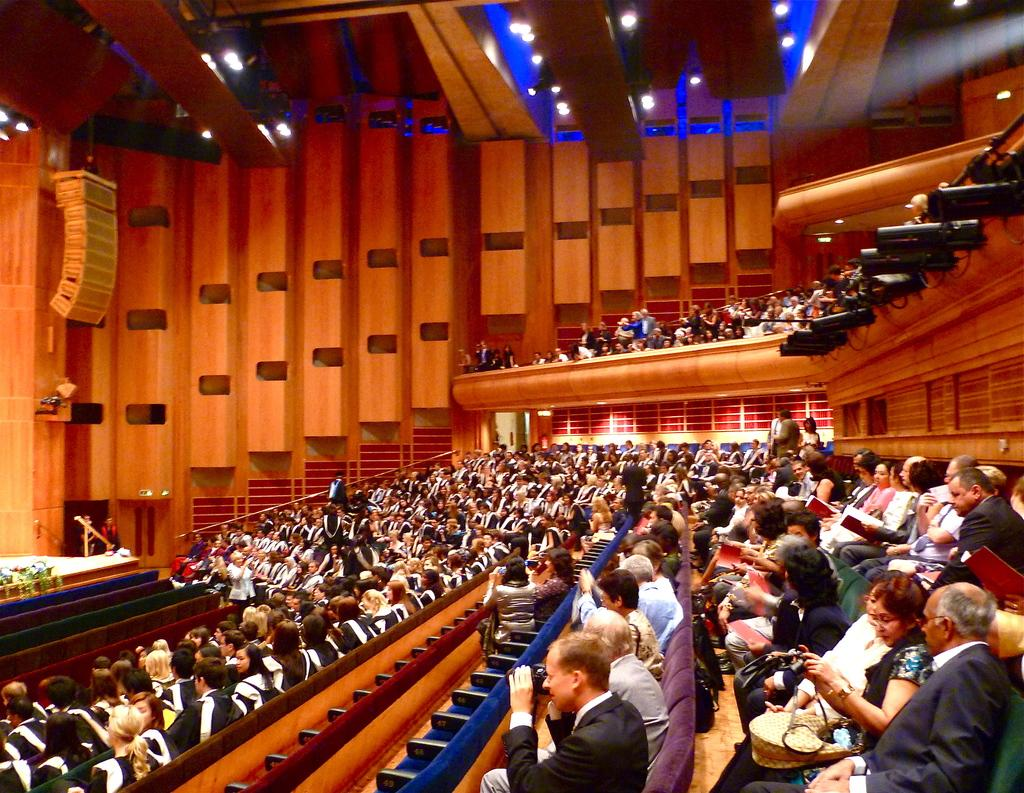What type of space is shown in the image? The image appears to depict an auditorium. What are the people in the image doing? There is a group of people sitting on sofa chairs. What can be seen in the ceiling of the auditorium? There are ceiling lights visible in the image. Can you see a girl swimming in the lake in the image? There is no lake or girl swimming in the image; it depicts an auditorium with people sitting on sofa chairs. What type of voice can be heard coming from the stage in the image? There is no indication of any voice or stage performance in the image, as it only shows an auditorium with people sitting on sofa chairs. 